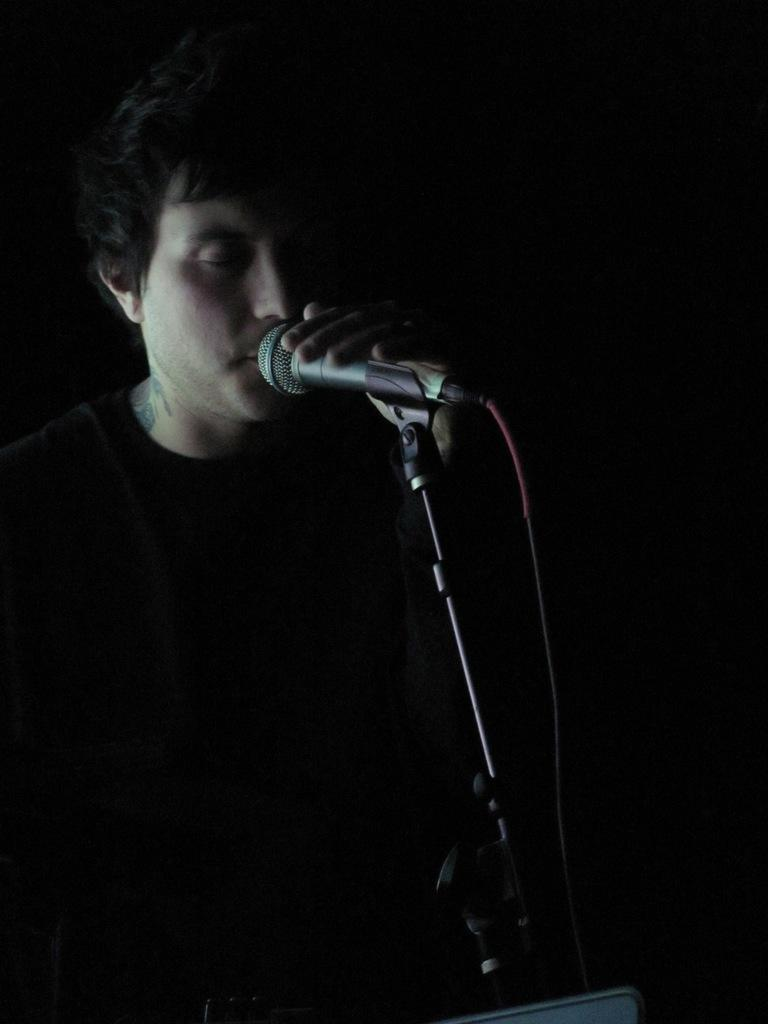Who or what is the main subject in the image? There is a person in the center of the image. What is the person holding in the image? The person is holding a microphone. Can you describe the background of the image? The background of the image is dark. How many tomatoes can be seen in the image? There are no tomatoes present in the image. Is there a seat for the person to sit on in the image? The image does not show a seat for the person to sit on. 